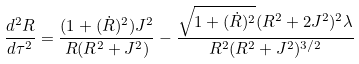<formula> <loc_0><loc_0><loc_500><loc_500>\frac { d ^ { 2 } R } { d \tau ^ { 2 } } = \frac { ( 1 + ( \dot { R } ) ^ { 2 } ) J ^ { 2 } } { R ( R ^ { 2 } + J ^ { 2 } ) } - \frac { \sqrt { 1 + ( \dot { R } ) ^ { 2 } } ( R ^ { 2 } + 2 J ^ { 2 } ) ^ { 2 } \lambda } { R ^ { 2 } ( R ^ { 2 } + J ^ { 2 } ) ^ { 3 / 2 } }</formula> 